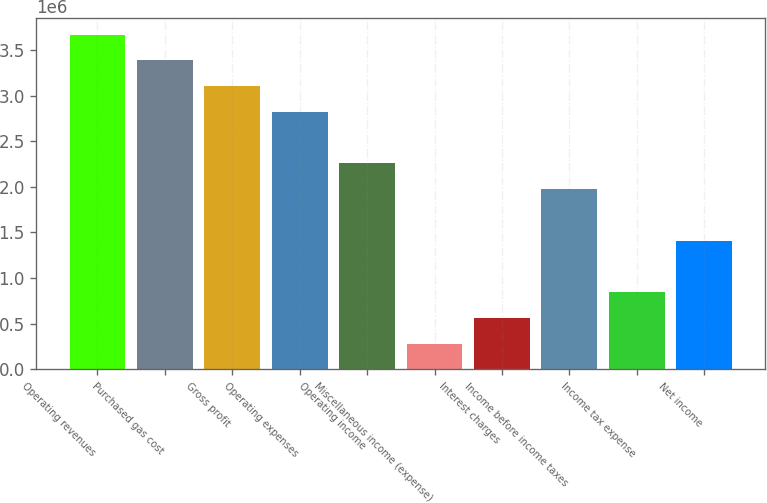<chart> <loc_0><loc_0><loc_500><loc_500><bar_chart><fcel>Operating revenues<fcel>Purchased gas cost<fcel>Gross profit<fcel>Operating expenses<fcel>Operating income<fcel>Miscellaneous income (expense)<fcel>Interest charges<fcel>Income before income taxes<fcel>Income tax expense<fcel>Net income<nl><fcel>3.66777e+06<fcel>3.38563e+06<fcel>3.1035e+06<fcel>2.82136e+06<fcel>2.25709e+06<fcel>282141<fcel>564276<fcel>1.97495e+06<fcel>846412<fcel>1.41068e+06<nl></chart> 